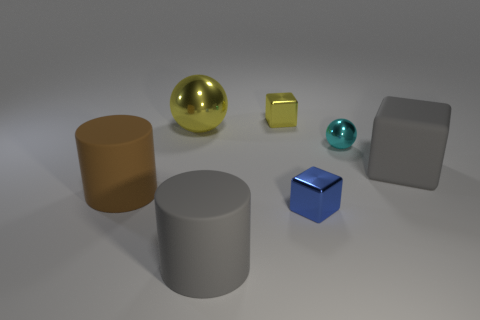Can you describe the texture and material finish of the objects? Certainly! The objects appear to have a smooth texture with a mix of matte and reflective material finishes. The gold sphere and turquoise sphere have highly reflective surfaces suggesting a metallic or glossy finish. The other objects, including the bronze cylinder, yellow and blue cubes, and the large gray cube and cylinder, also show reflectiveness albeit at a lower intensity, indicating a less glossy material, possibly a satin or semi-gloss finish. 